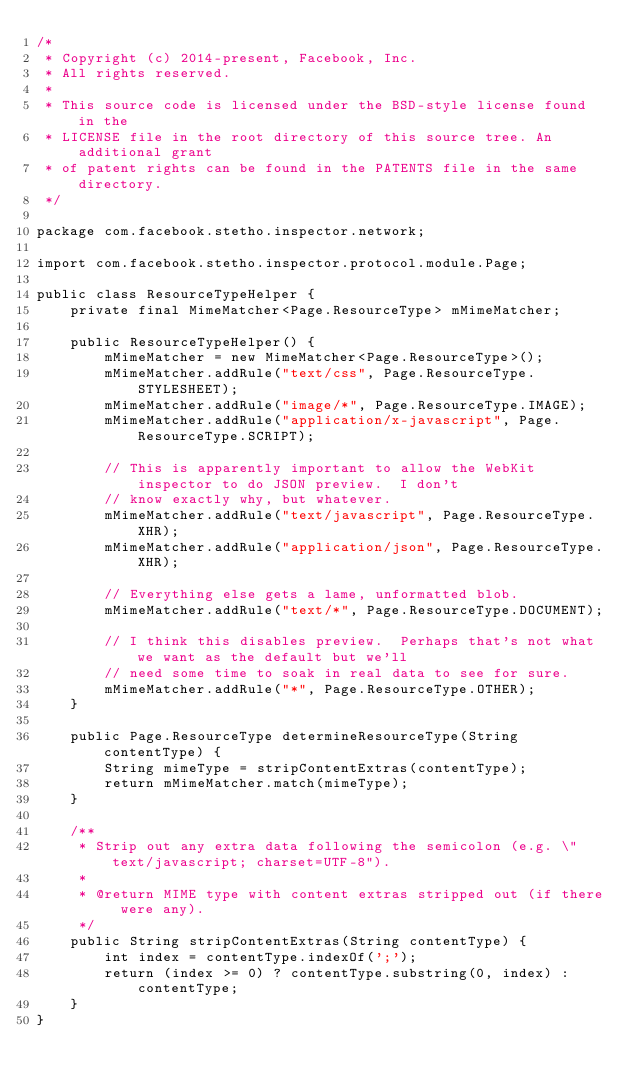<code> <loc_0><loc_0><loc_500><loc_500><_Java_>/*
 * Copyright (c) 2014-present, Facebook, Inc.
 * All rights reserved.
 *
 * This source code is licensed under the BSD-style license found in the
 * LICENSE file in the root directory of this source tree. An additional grant
 * of patent rights can be found in the PATENTS file in the same directory.
 */

package com.facebook.stetho.inspector.network;

import com.facebook.stetho.inspector.protocol.module.Page;

public class ResourceTypeHelper {
    private final MimeMatcher<Page.ResourceType> mMimeMatcher;

    public ResourceTypeHelper() {
        mMimeMatcher = new MimeMatcher<Page.ResourceType>();
        mMimeMatcher.addRule("text/css", Page.ResourceType.STYLESHEET);
        mMimeMatcher.addRule("image/*", Page.ResourceType.IMAGE);
        mMimeMatcher.addRule("application/x-javascript", Page.ResourceType.SCRIPT);

        // This is apparently important to allow the WebKit inspector to do JSON preview.  I don't
        // know exactly why, but whatever.
        mMimeMatcher.addRule("text/javascript", Page.ResourceType.XHR);
        mMimeMatcher.addRule("application/json", Page.ResourceType.XHR);

        // Everything else gets a lame, unformatted blob.
        mMimeMatcher.addRule("text/*", Page.ResourceType.DOCUMENT);

        // I think this disables preview.  Perhaps that's not what we want as the default but we'll
        // need some time to soak in real data to see for sure.
        mMimeMatcher.addRule("*", Page.ResourceType.OTHER);
    }

    public Page.ResourceType determineResourceType(String contentType) {
        String mimeType = stripContentExtras(contentType);
        return mMimeMatcher.match(mimeType);
    }

    /**
     * Strip out any extra data following the semicolon (e.g. \"text/javascript; charset=UTF-8").
     *
     * @return MIME type with content extras stripped out (if there were any).
     */
    public String stripContentExtras(String contentType) {
        int index = contentType.indexOf(';');
        return (index >= 0) ? contentType.substring(0, index) : contentType;
    }
}
</code> 